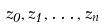Convert formula to latex. <formula><loc_0><loc_0><loc_500><loc_500>z _ { 0 } , z _ { 1 } , \dots , z _ { n }</formula> 